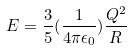<formula> <loc_0><loc_0><loc_500><loc_500>E = \frac { 3 } { 5 } ( \frac { 1 } { 4 \pi \epsilon _ { 0 } } ) \frac { Q ^ { 2 } } { R }</formula> 